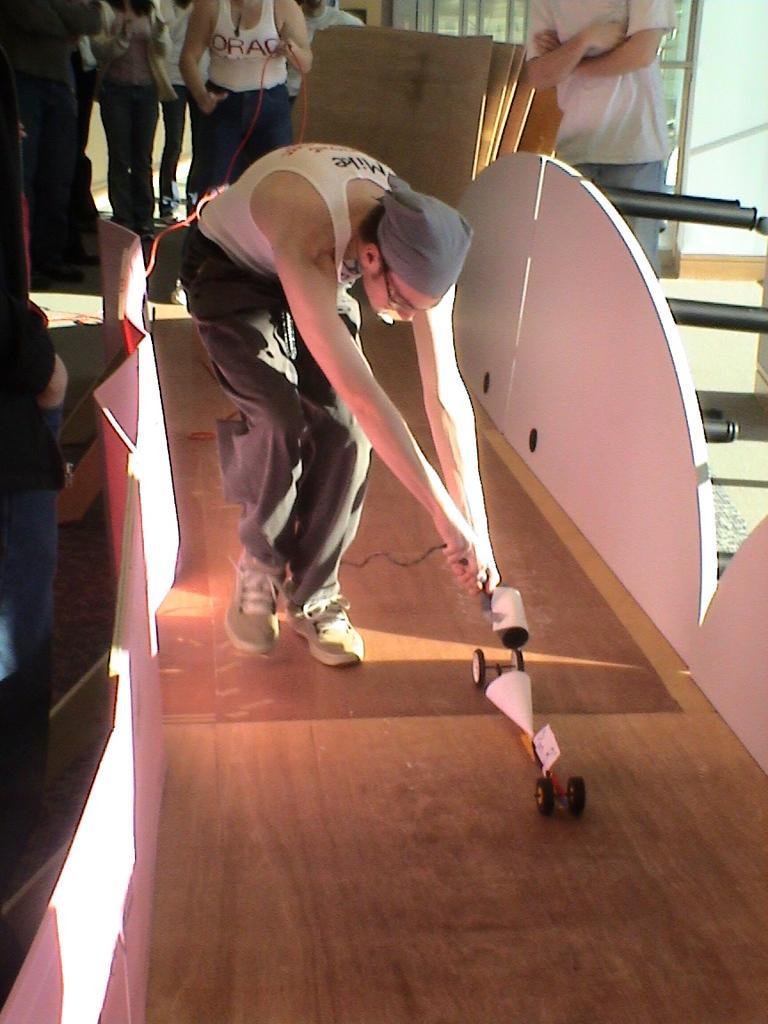Can you describe this image briefly? In this image we can see a few people, among the one person is playing with an object on the floor, we can see some boards, poles and the wall. 